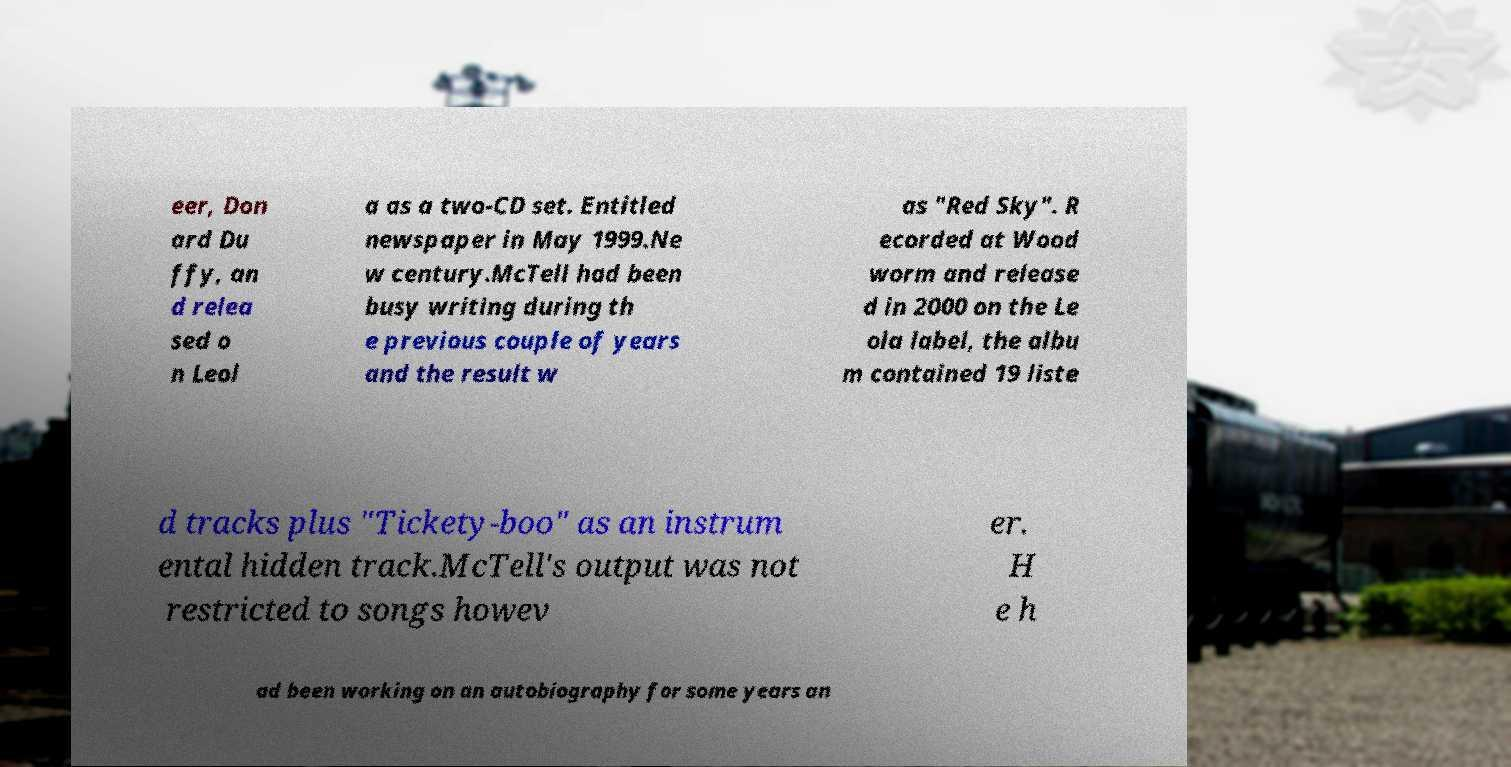What messages or text are displayed in this image? I need them in a readable, typed format. eer, Don ard Du ffy, an d relea sed o n Leol a as a two-CD set. Entitled newspaper in May 1999.Ne w century.McTell had been busy writing during th e previous couple of years and the result w as "Red Sky". R ecorded at Wood worm and release d in 2000 on the Le ola label, the albu m contained 19 liste d tracks plus "Tickety-boo" as an instrum ental hidden track.McTell's output was not restricted to songs howev er. H e h ad been working on an autobiography for some years an 